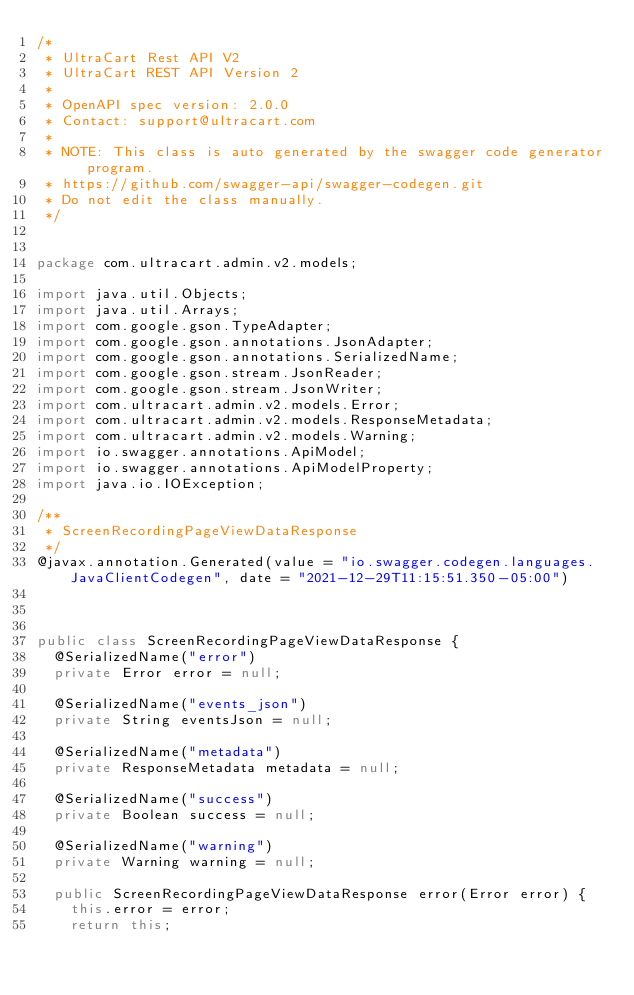Convert code to text. <code><loc_0><loc_0><loc_500><loc_500><_Java_>/*
 * UltraCart Rest API V2
 * UltraCart REST API Version 2
 *
 * OpenAPI spec version: 2.0.0
 * Contact: support@ultracart.com
 *
 * NOTE: This class is auto generated by the swagger code generator program.
 * https://github.com/swagger-api/swagger-codegen.git
 * Do not edit the class manually.
 */


package com.ultracart.admin.v2.models;

import java.util.Objects;
import java.util.Arrays;
import com.google.gson.TypeAdapter;
import com.google.gson.annotations.JsonAdapter;
import com.google.gson.annotations.SerializedName;
import com.google.gson.stream.JsonReader;
import com.google.gson.stream.JsonWriter;
import com.ultracart.admin.v2.models.Error;
import com.ultracart.admin.v2.models.ResponseMetadata;
import com.ultracart.admin.v2.models.Warning;
import io.swagger.annotations.ApiModel;
import io.swagger.annotations.ApiModelProperty;
import java.io.IOException;

/**
 * ScreenRecordingPageViewDataResponse
 */
@javax.annotation.Generated(value = "io.swagger.codegen.languages.JavaClientCodegen", date = "2021-12-29T11:15:51.350-05:00")



public class ScreenRecordingPageViewDataResponse {
  @SerializedName("error")
  private Error error = null;

  @SerializedName("events_json")
  private String eventsJson = null;

  @SerializedName("metadata")
  private ResponseMetadata metadata = null;

  @SerializedName("success")
  private Boolean success = null;

  @SerializedName("warning")
  private Warning warning = null;

  public ScreenRecordingPageViewDataResponse error(Error error) {
    this.error = error;
    return this;</code> 